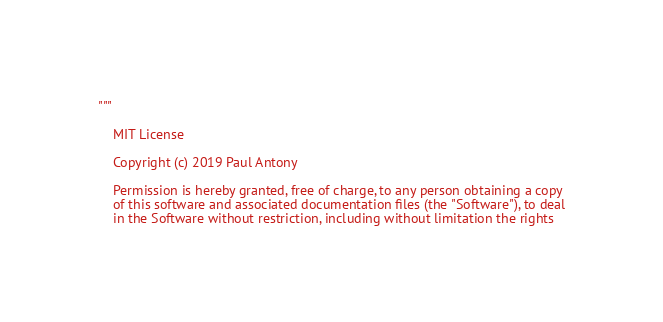<code> <loc_0><loc_0><loc_500><loc_500><_Python_>"""

    MIT License

    Copyright (c) 2019 Paul Antony

    Permission is hereby granted, free of charge, to any person obtaining a copy
    of this software and associated documentation files (the "Software"), to deal
    in the Software without restriction, including without limitation the rights</code> 